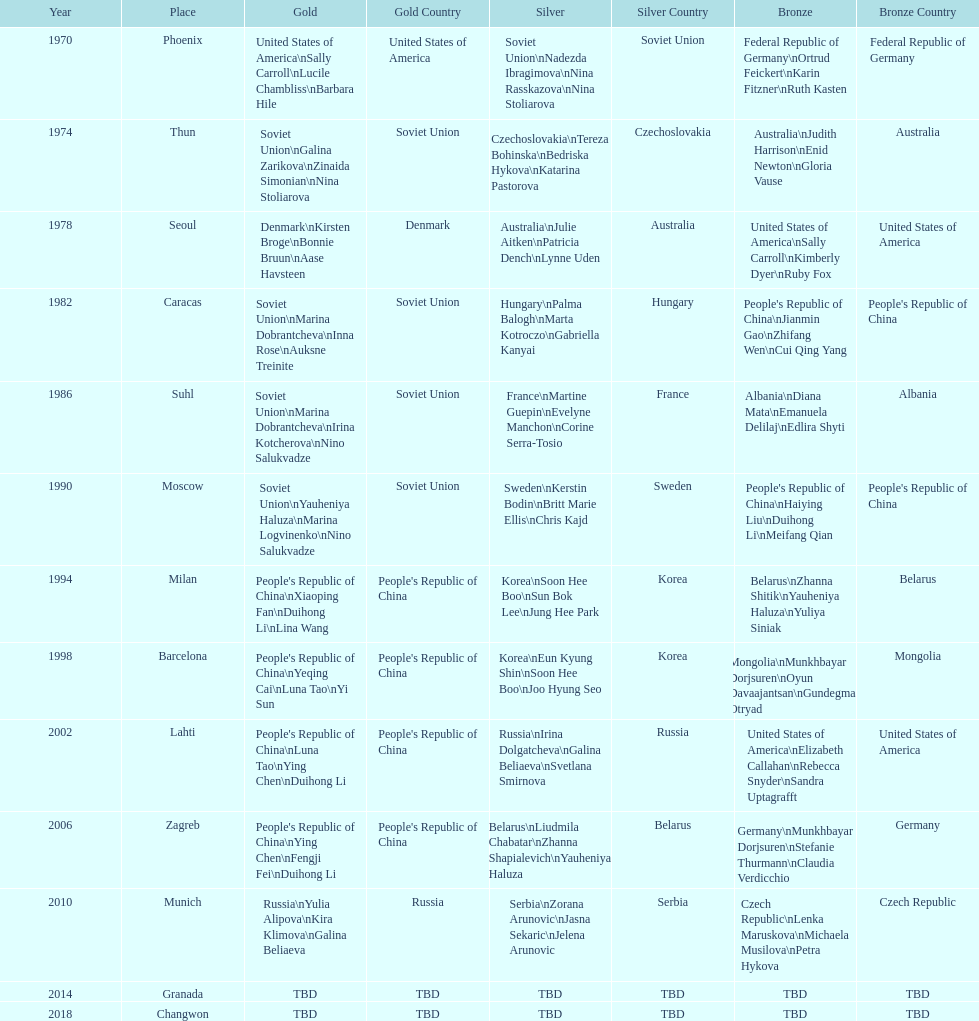How many times has germany won bronze? 2. 